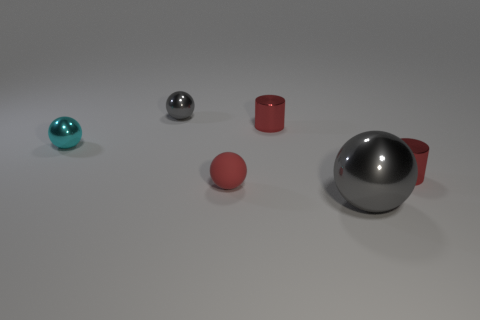What size is the metallic thing that is the same color as the big sphere?
Offer a very short reply. Small. Is there any other thing that has the same material as the tiny red sphere?
Your answer should be very brief. No. Is the number of tiny red balls in front of the large sphere the same as the number of shiny things that are in front of the small cyan object?
Make the answer very short. No. The cylinder that is in front of the cylinder that is on the left side of the gray shiny sphere that is in front of the red rubber sphere is made of what material?
Your answer should be compact. Metal. What is the size of the red object that is both to the left of the large gray metallic thing and behind the matte thing?
Your response must be concise. Small. Does the small cyan thing have the same shape as the small gray thing?
Keep it short and to the point. Yes. The big object that is the same material as the tiny cyan object is what shape?
Provide a succinct answer. Sphere. What number of tiny things are either cyan rubber objects or gray things?
Offer a terse response. 1. There is a gray object that is on the right side of the small red matte object; is there a metallic thing that is in front of it?
Your answer should be compact. No. Are any large blue rubber spheres visible?
Your answer should be very brief. No. 